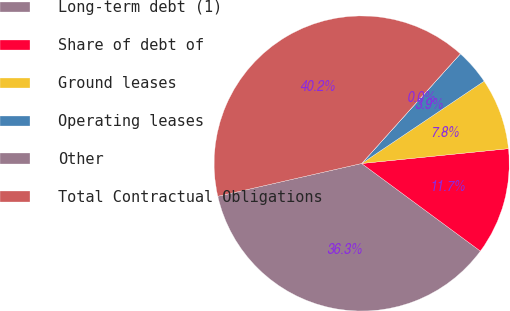<chart> <loc_0><loc_0><loc_500><loc_500><pie_chart><fcel>Long-term debt (1)<fcel>Share of debt of<fcel>Ground leases<fcel>Operating leases<fcel>Other<fcel>Total Contractual Obligations<nl><fcel>36.32%<fcel>11.72%<fcel>7.82%<fcel>3.91%<fcel>0.01%<fcel>40.23%<nl></chart> 